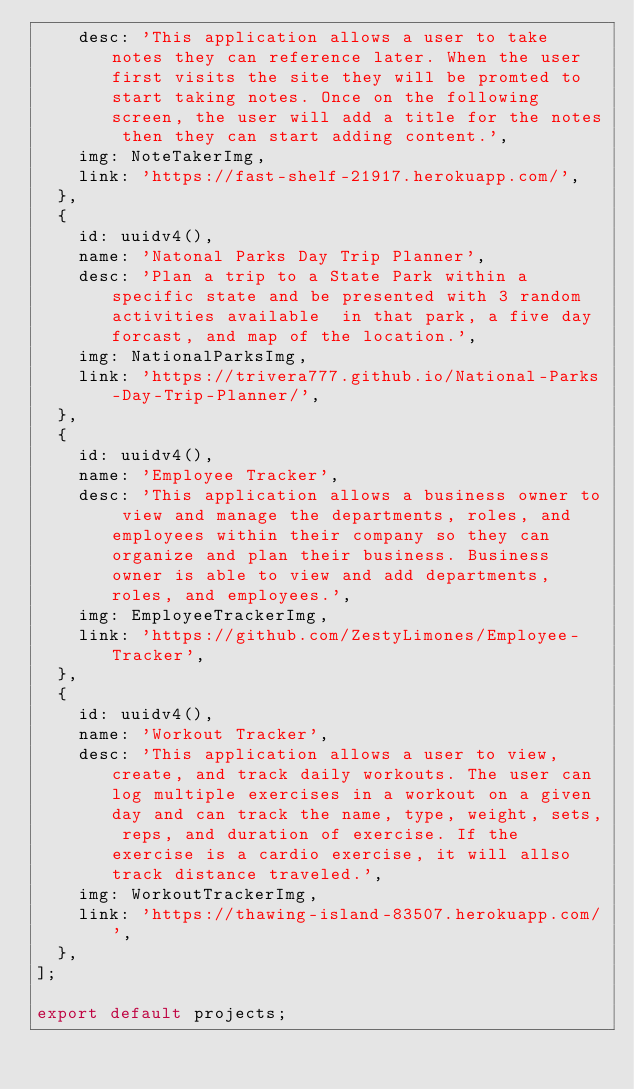<code> <loc_0><loc_0><loc_500><loc_500><_JavaScript_>    desc: 'This application allows a user to take notes they can reference later. When the user first visits the site they will be promted to start taking notes. Once on the following screen, the user will add a title for the notes then they can start adding content.',
    img: NoteTakerImg,
    link: 'https://fast-shelf-21917.herokuapp.com/',
  },
  {
    id: uuidv4(),
    name: 'Natonal Parks Day Trip Planner',
    desc: 'Plan a trip to a State Park within a specific state and be presented with 3 random activities available  in that park, a five day forcast, and map of the location.',
    img: NationalParksImg,
    link: 'https://trivera777.github.io/National-Parks-Day-Trip-Planner/',
  },
  {
    id: uuidv4(),
    name: 'Employee Tracker',
    desc: 'This application allows a business owner to view and manage the departments, roles, and employees within their company so they can organize and plan their business. Business owner is able to view and add departments, roles, and employees.',
    img: EmployeeTrackerImg,
    link: 'https://github.com/ZestyLimones/Employee-Tracker',
  },
  {
    id: uuidv4(),
    name: 'Workout Tracker',
    desc: 'This application allows a user to view, create, and track daily workouts. The user can log multiple exercises in a workout on a given day and can track the name, type, weight, sets, reps, and duration of exercise. If the exercise is a cardio exercise, it will allso track distance traveled.',
    img: WorkoutTrackerImg,
    link: 'https://thawing-island-83507.herokuapp.com/',
  },
];

export default projects;
</code> 